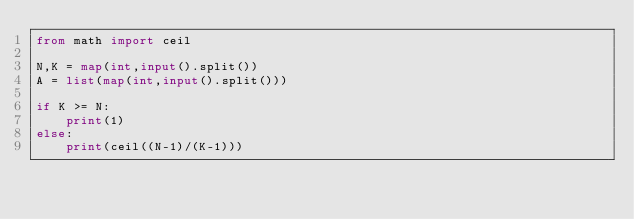<code> <loc_0><loc_0><loc_500><loc_500><_Python_>from math import ceil

N,K = map(int,input().split())
A = list(map(int,input().split()))

if K >= N:
    print(1)
else:
    print(ceil((N-1)/(K-1)))</code> 